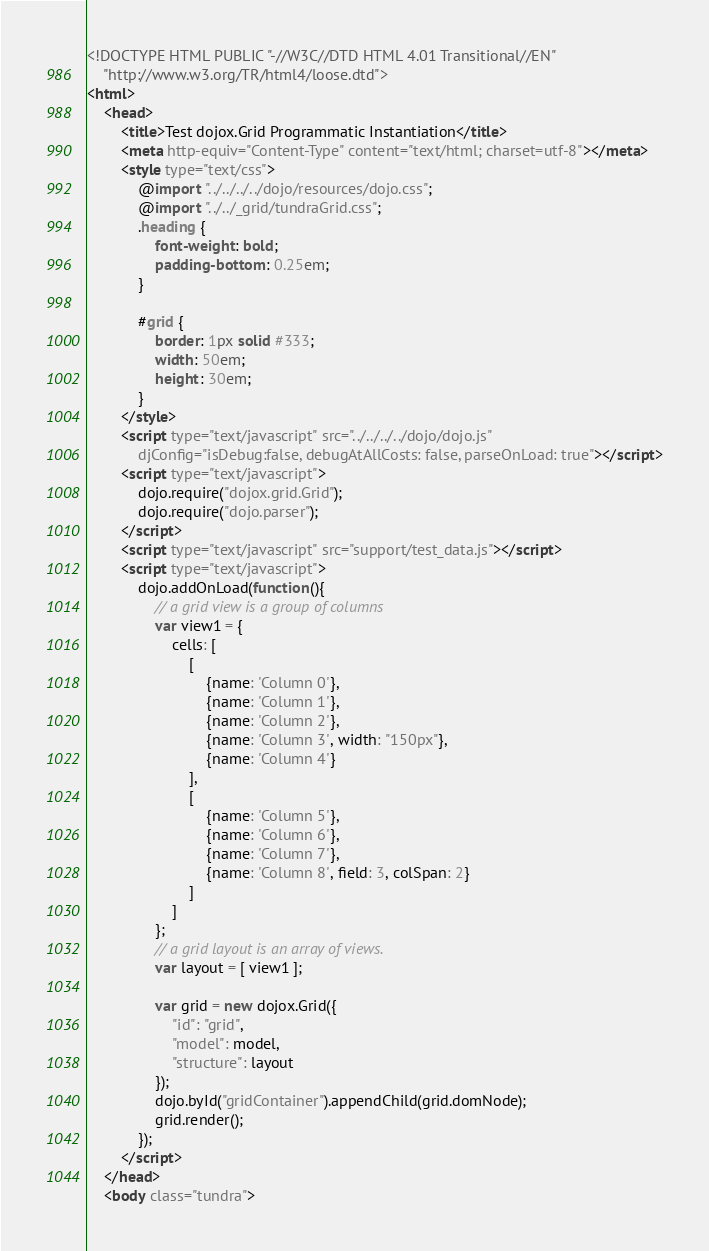Convert code to text. <code><loc_0><loc_0><loc_500><loc_500><_HTML_><!DOCTYPE HTML PUBLIC "-//W3C//DTD HTML 4.01 Transitional//EN" 
	"http://www.w3.org/TR/html4/loose.dtd">
<html>
	<head>
		<title>Test dojox.Grid Programmatic Instantiation</title>
		<meta http-equiv="Content-Type" content="text/html; charset=utf-8"></meta>
		<style type="text/css">
			@import "../../../../dojo/resources/dojo.css";
			@import "../../_grid/tundraGrid.css";
			.heading {
				font-weight: bold;
				padding-bottom: 0.25em;
			}
					
			#grid { 
				border: 1px solid #333;
				width: 50em;
				height: 30em;
			}
		</style>
		<script type="text/javascript" src="../../../../dojo/dojo.js" 
			djConfig="isDebug:false, debugAtAllCosts: false, parseOnLoad: true"></script>
		<script type="text/javascript">
			dojo.require("dojox.grid.Grid");
			dojo.require("dojo.parser");
		</script>
		<script type="text/javascript" src="support/test_data.js"></script>
		<script type="text/javascript">
			dojo.addOnLoad(function(){
				// a grid view is a group of columns
				var view1 = {
					cells: [
						[
							{name: 'Column 0'}, 
							{name: 'Column 1'}, 
							{name: 'Column 2'}, 
							{name: 'Column 3', width: "150px"}, 
							{name: 'Column 4'}
						],
						[
							{name: 'Column 5'}, 
							{name: 'Column 6'}, 
							{name: 'Column 7'}, 
							{name: 'Column 8', field: 3, colSpan: 2}
						]
					]
				};
				// a grid layout is an array of views.
				var layout = [ view1 ];

				var grid = new dojox.Grid({
					"id": "grid",
					"model": model,
					"structure": layout
				});
				dojo.byId("gridContainer").appendChild(grid.domNode);
				grid.render();
			});
		</script>
	</head>
	<body class="tundra"></code> 